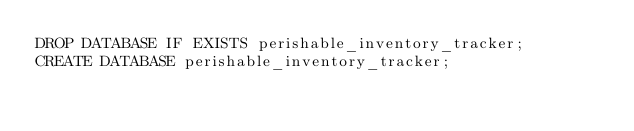<code> <loc_0><loc_0><loc_500><loc_500><_SQL_>DROP DATABASE IF EXISTS perishable_inventory_tracker;
CREATE DATABASE perishable_inventory_tracker;</code> 